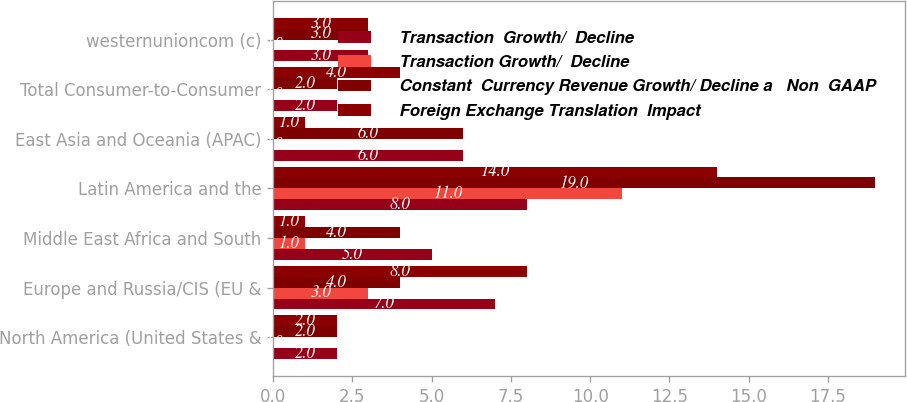<chart> <loc_0><loc_0><loc_500><loc_500><stacked_bar_chart><ecel><fcel>North America (United States &<fcel>Europe and Russia/CIS (EU &<fcel>Middle East Africa and South<fcel>Latin America and the<fcel>East Asia and Oceania (APAC)<fcel>Total Consumer-to-Consumer<fcel>westernunioncom (c)<nl><fcel>Transaction  Growth/  Decline<fcel>2<fcel>7<fcel>5<fcel>8<fcel>6<fcel>2<fcel>3<nl><fcel>Transaction Growth/  Decline<fcel>0<fcel>3<fcel>1<fcel>11<fcel>0<fcel>0<fcel>0<nl><fcel>Constant  Currency Revenue Growth/ Decline a   Non  GAAP<fcel>2<fcel>4<fcel>4<fcel>19<fcel>6<fcel>2<fcel>3<nl><fcel>Foreign Exchange Translation  Impact<fcel>2<fcel>8<fcel>1<fcel>14<fcel>1<fcel>4<fcel>3<nl></chart> 